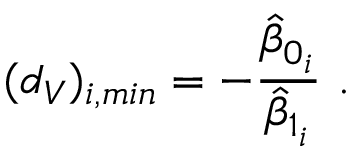<formula> <loc_0><loc_0><loc_500><loc_500>( d _ { V } ) _ { i , \min } = - \frac { \hat { \beta } _ { 0 _ { i } } } { \hat { \beta } _ { 1 _ { i } } } \ .</formula> 